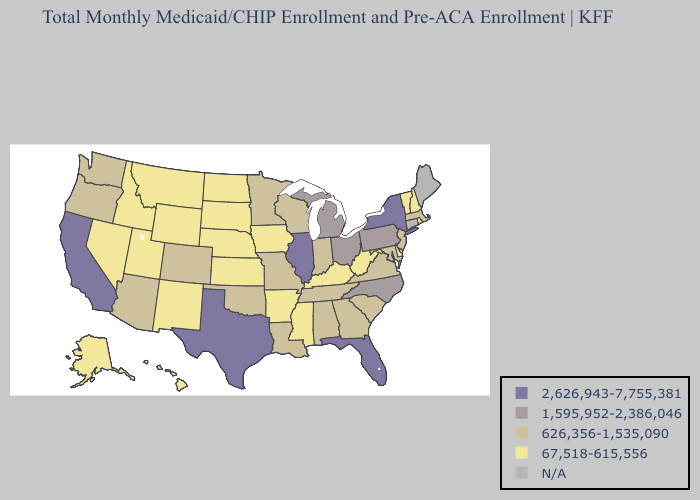Name the states that have a value in the range N/A?
Short answer required. Connecticut, Maine. Does New Jersey have the lowest value in the USA?
Concise answer only. No. What is the highest value in the USA?
Quick response, please. 2,626,943-7,755,381. What is the lowest value in states that border California?
Answer briefly. 67,518-615,556. What is the value of Arizona?
Write a very short answer. 626,356-1,535,090. Which states have the lowest value in the West?
Keep it brief. Alaska, Hawaii, Idaho, Montana, Nevada, New Mexico, Utah, Wyoming. What is the lowest value in the USA?
Quick response, please. 67,518-615,556. What is the value of Delaware?
Concise answer only. 67,518-615,556. What is the highest value in the USA?
Be succinct. 2,626,943-7,755,381. What is the lowest value in the West?
Answer briefly. 67,518-615,556. Does Minnesota have the lowest value in the MidWest?
Concise answer only. No. Name the states that have a value in the range 1,595,952-2,386,046?
Concise answer only. Michigan, North Carolina, Ohio, Pennsylvania. Name the states that have a value in the range 626,356-1,535,090?
Concise answer only. Alabama, Arizona, Colorado, Georgia, Indiana, Louisiana, Maryland, Massachusetts, Minnesota, Missouri, New Jersey, Oklahoma, Oregon, South Carolina, Tennessee, Virginia, Washington, Wisconsin. What is the value of Minnesota?
Answer briefly. 626,356-1,535,090. 